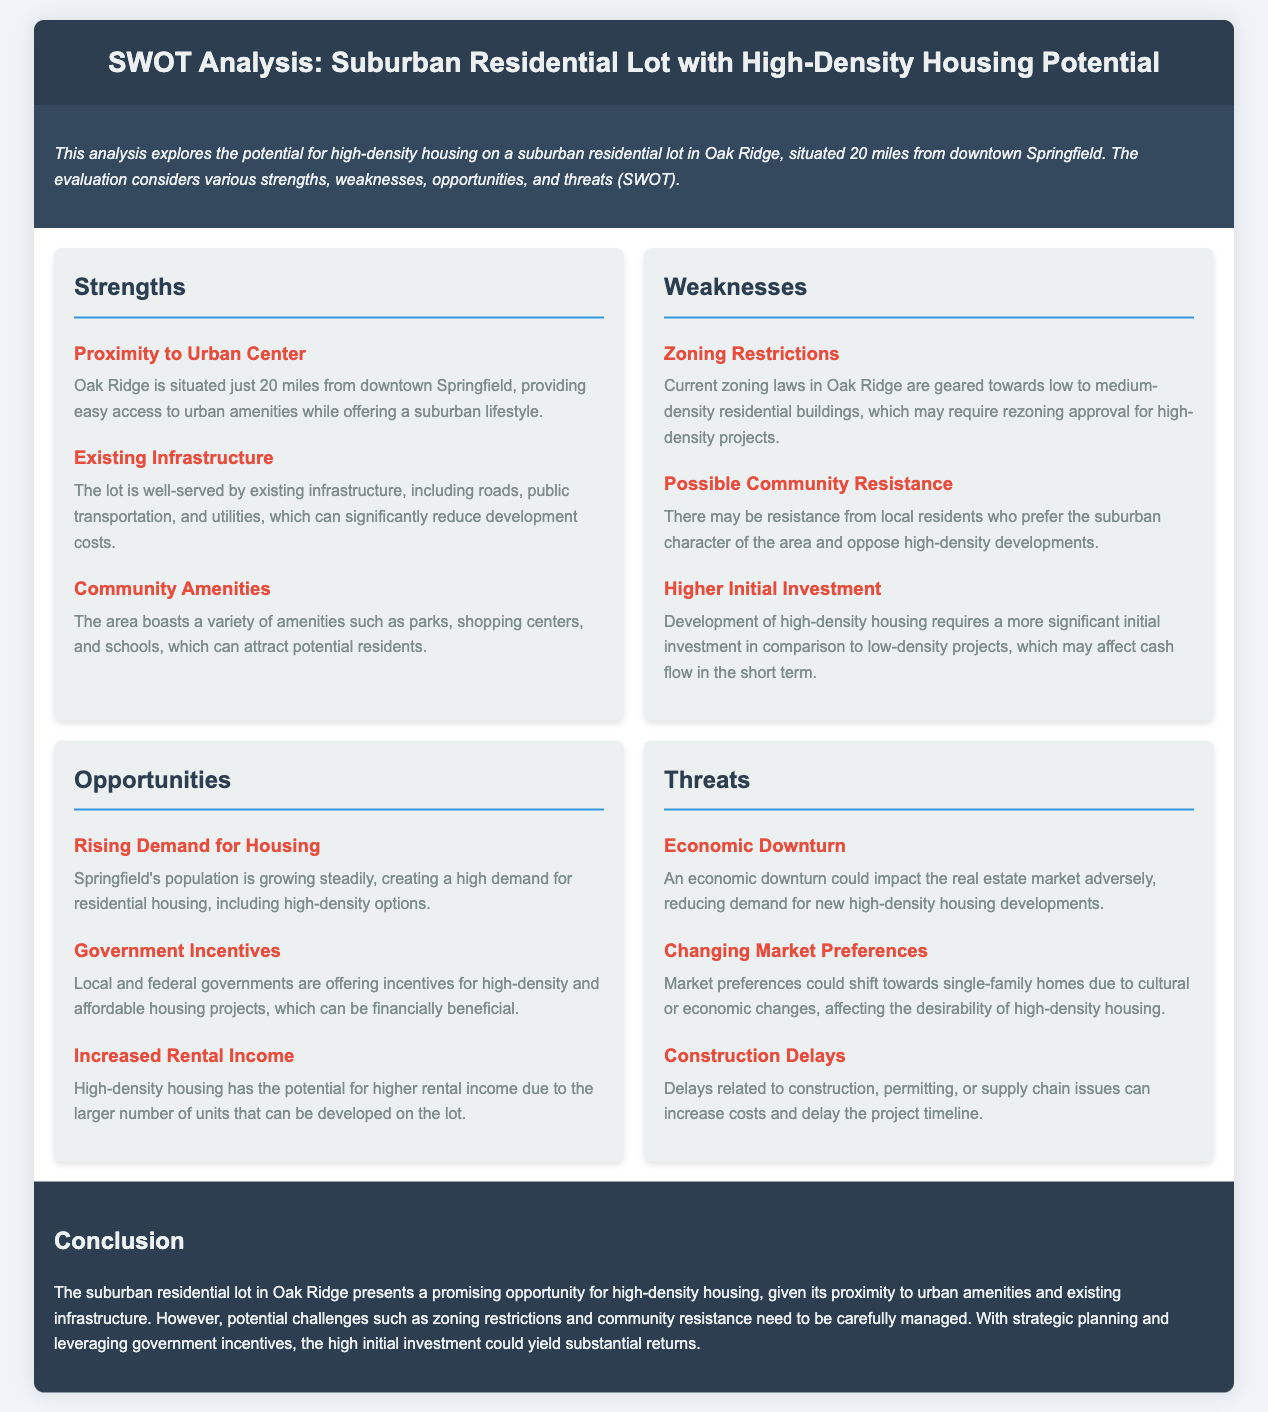What is the distance of Oak Ridge from downtown Springfield? The document states that Oak Ridge is situated just 20 miles from downtown Springfield.
Answer: 20 miles What are the residential zoning laws currently geared towards? The document indicates that current zoning laws in Oak Ridge are geared towards low to medium-density residential buildings.
Answer: Low to medium-density What type of housing has the potential for higher rental income? According to the document, high-density housing has the potential for higher rental income.
Answer: High-density housing What is a possible threat to the real estate market mentioned in the analysis? The document mentions that an economic downturn could impact the real estate market adversely.
Answer: Economic downturn Which government initiatives could benefit high-density housing projects? The document notes that local and federal governments are offering incentives for high-density and affordable housing projects.
Answer: Government incentives Which community feature could attract potential residents? The document states that the area boasts a variety of amenities such as parks, shopping centers, and schools.
Answer: Parks, shopping centers, schools What initial financial consideration is stated as a weakness for high-density housing development? The document points out that development of high-density housing requires a more significant initial investment.
Answer: Higher initial investment What may cause community resistance against high-density developments? The document mentions that there may be resistance from local residents who prefer the suburban character of the area.
Answer: Community character preference 